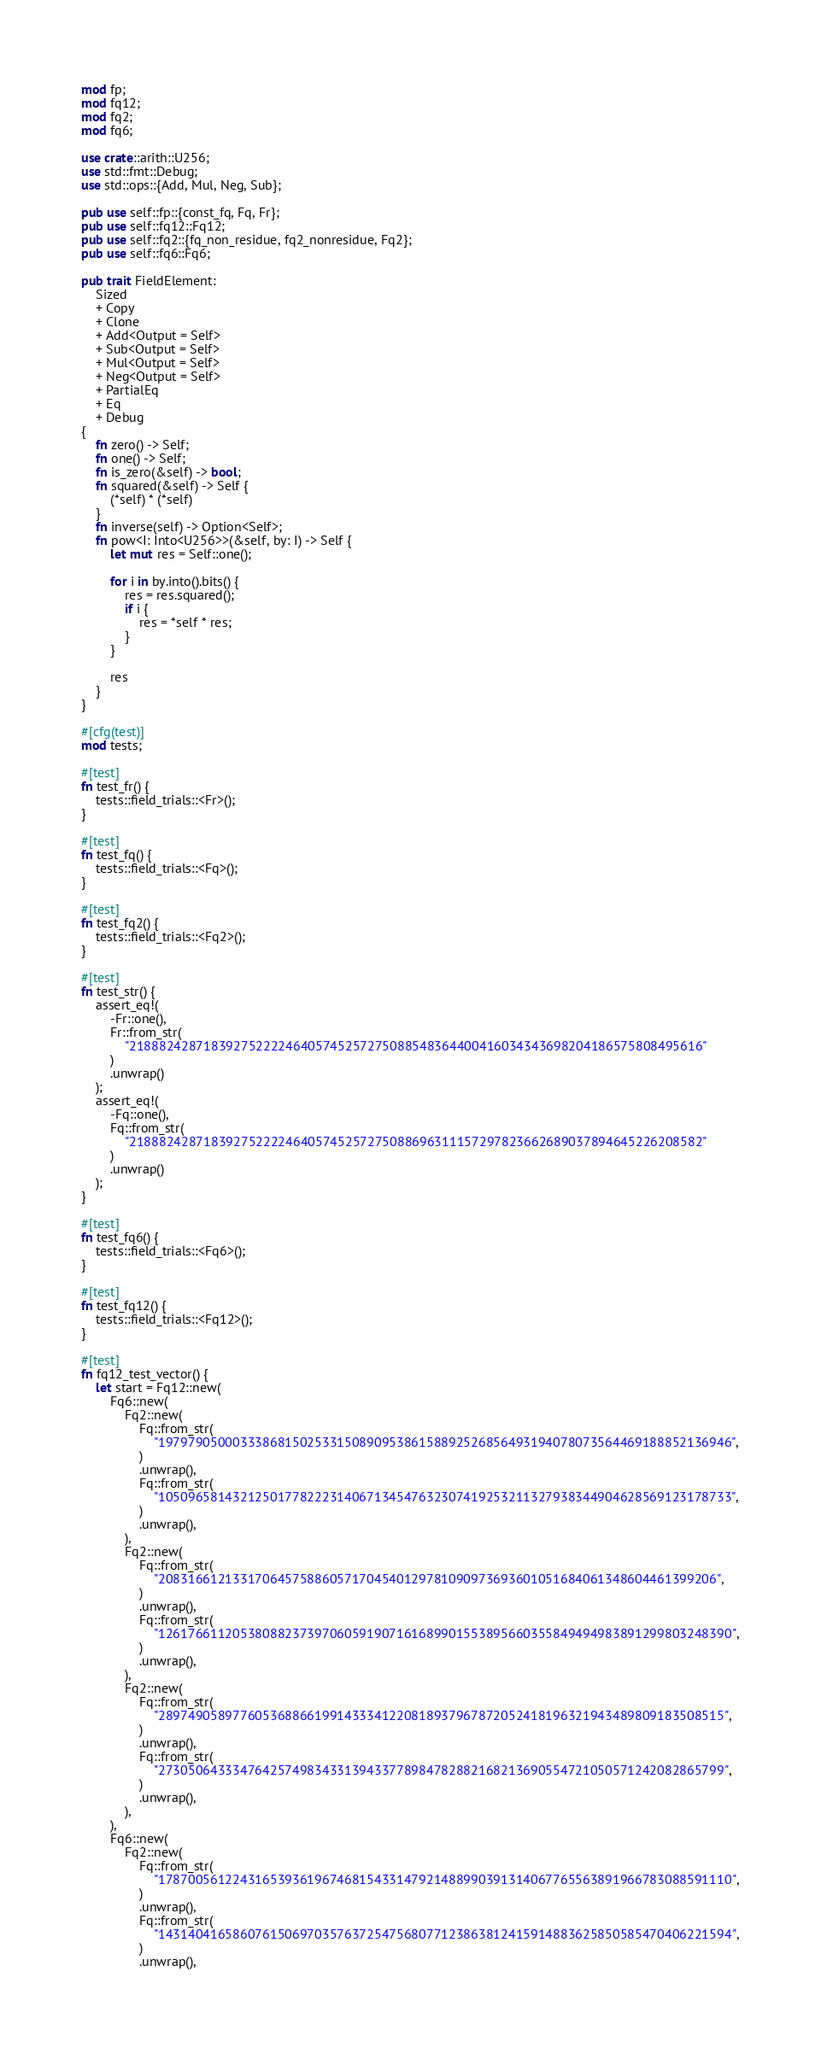Convert code to text. <code><loc_0><loc_0><loc_500><loc_500><_Rust_>mod fp;
mod fq12;
mod fq2;
mod fq6;

use crate::arith::U256;
use std::fmt::Debug;
use std::ops::{Add, Mul, Neg, Sub};

pub use self::fp::{const_fq, Fq, Fr};
pub use self::fq12::Fq12;
pub use self::fq2::{fq_non_residue, fq2_nonresidue, Fq2};
pub use self::fq6::Fq6;

pub trait FieldElement:
    Sized
    + Copy
    + Clone
    + Add<Output = Self>
    + Sub<Output = Self>
    + Mul<Output = Self>
    + Neg<Output = Self>
    + PartialEq
    + Eq
    + Debug
{
    fn zero() -> Self;
    fn one() -> Self;
    fn is_zero(&self) -> bool;
    fn squared(&self) -> Self {
        (*self) * (*self)
    }
    fn inverse(self) -> Option<Self>;
    fn pow<I: Into<U256>>(&self, by: I) -> Self {
        let mut res = Self::one();

        for i in by.into().bits() {
            res = res.squared();
            if i {
                res = *self * res;
            }
        }

        res
    }
}

#[cfg(test)]
mod tests;

#[test]
fn test_fr() {
    tests::field_trials::<Fr>();
}

#[test]
fn test_fq() {
    tests::field_trials::<Fq>();
}

#[test]
fn test_fq2() {
    tests::field_trials::<Fq2>();
}

#[test]
fn test_str() {
    assert_eq!(
        -Fr::one(),
        Fr::from_str(
            "21888242871839275222246405745257275088548364400416034343698204186575808495616"
        )
        .unwrap()
    );
    assert_eq!(
        -Fq::one(),
        Fq::from_str(
            "21888242871839275222246405745257275088696311157297823662689037894645226208582"
        )
        .unwrap()
    );
}

#[test]
fn test_fq6() {
    tests::field_trials::<Fq6>();
}

#[test]
fn test_fq12() {
    tests::field_trials::<Fq12>();
}

#[test]
fn fq12_test_vector() {
    let start = Fq12::new(
        Fq6::new(
            Fq2::new(
                Fq::from_str(
                    "19797905000333868150253315089095386158892526856493194078073564469188852136946",
                )
                .unwrap(),
                Fq::from_str(
                    "10509658143212501778222314067134547632307419253211327938344904628569123178733",
                )
                .unwrap(),
            ),
            Fq2::new(
                Fq::from_str(
                    "208316612133170645758860571704540129781090973693601051684061348604461399206",
                )
                .unwrap(),
                Fq::from_str(
                    "12617661120538088237397060591907161689901553895660355849494983891299803248390",
                )
                .unwrap(),
            ),
            Fq2::new(
                Fq::from_str(
                    "2897490589776053688661991433341220818937967872052418196321943489809183508515",
                )
                .unwrap(),
                Fq::from_str(
                    "2730506433347642574983433139433778984782882168213690554721050571242082865799",
                )
                .unwrap(),
            ),
        ),
        Fq6::new(
            Fq2::new(
                Fq::from_str(
                    "17870056122431653936196746815433147921488990391314067765563891966783088591110",
                )
                .unwrap(),
                Fq::from_str(
                    "14314041658607615069703576372547568077123863812415914883625850585470406221594",
                )
                .unwrap(),</code> 